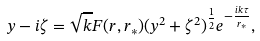Convert formula to latex. <formula><loc_0><loc_0><loc_500><loc_500>y - i \zeta = \sqrt { k } F ( r , r _ { * } ) ( y ^ { 2 } + \zeta ^ { 2 } ) ^ { \frac { 1 } { 2 } } e ^ { - \frac { i k \tau } { r _ { * } } } ,</formula> 